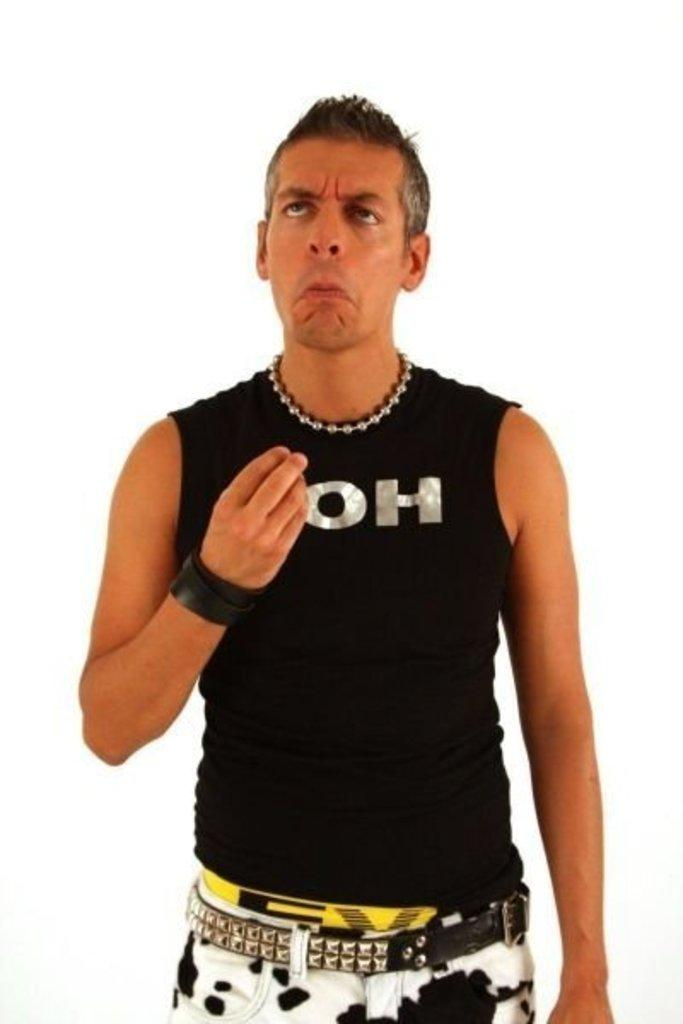<image>
Create a compact narrative representing the image presented. A man has a tank top on with the letters OH on the front. 